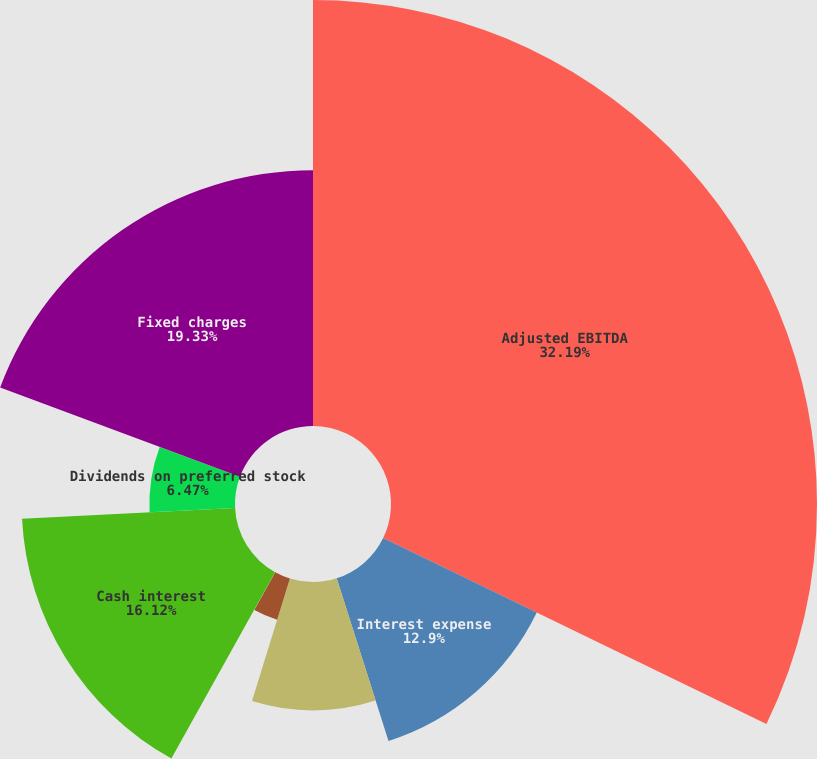Convert chart to OTSL. <chart><loc_0><loc_0><loc_500><loc_500><pie_chart><fcel>Adjusted EBITDA<fcel>Interest expense<fcel>Add capitalized interest<fcel>Less amortization of loan fees<fcel>Less amortization of debt<fcel>Cash interest<fcel>Dividends on preferred stock<fcel>Fixed charges<nl><fcel>32.19%<fcel>12.9%<fcel>9.69%<fcel>3.26%<fcel>0.04%<fcel>16.12%<fcel>6.47%<fcel>19.33%<nl></chart> 